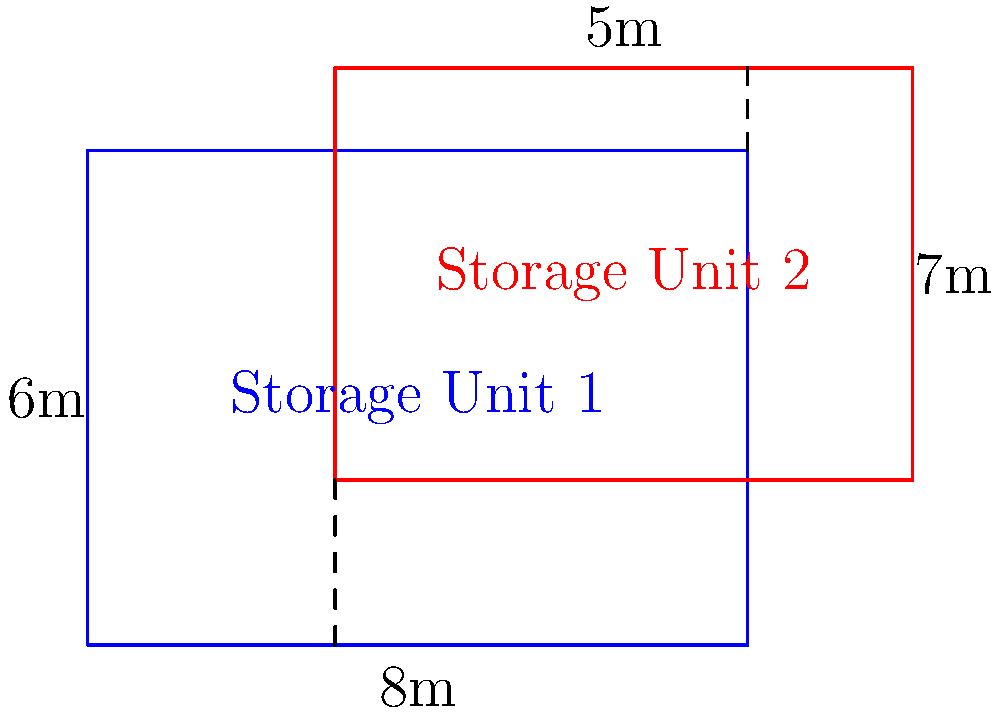Two rectangular drug storage units are placed in a laboratory as shown in the diagram. Storage Unit 1 measures 8m by 6m, while Storage Unit 2 measures 7m by 5m. If the units overlap as illustrated, what is the area of the overlapping region? To find the area of overlap between the two storage units, we need to determine the dimensions of the overlapping rectangle:

1. Width of overlap:
   - Storage Unit 1 extends 8m horizontally
   - Storage Unit 2 starts 3m from the left edge of Unit 1
   - Overlap width = $8m - 3m = 5m$

2. Height of overlap:
   - Storage Unit 1 is 6m tall
   - Storage Unit 2 extends 1m above Unit 1
   - Overlap height = $6m - 2m = 4m$ (where 2m is the distance from the bottom of Unit 1 to the bottom of Unit 2)

3. Calculate the area of overlap:
   Area = width × height
   $A = 5m \times 4m = 20m^2$

Therefore, the area of the overlapping region between the two drug storage units is 20 square meters.
Answer: $20m^2$ 